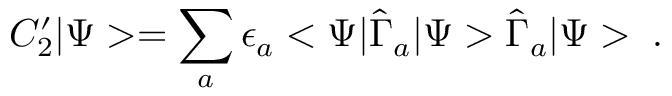Convert formula to latex. <formula><loc_0><loc_0><loc_500><loc_500>C _ { 2 } ^ { \prime } | \Psi > = \sum _ { a } \epsilon _ { a } < \Psi | \hat { \Gamma } _ { a } | \Psi > \hat { \Gamma } _ { a } | \Psi > \, .</formula> 